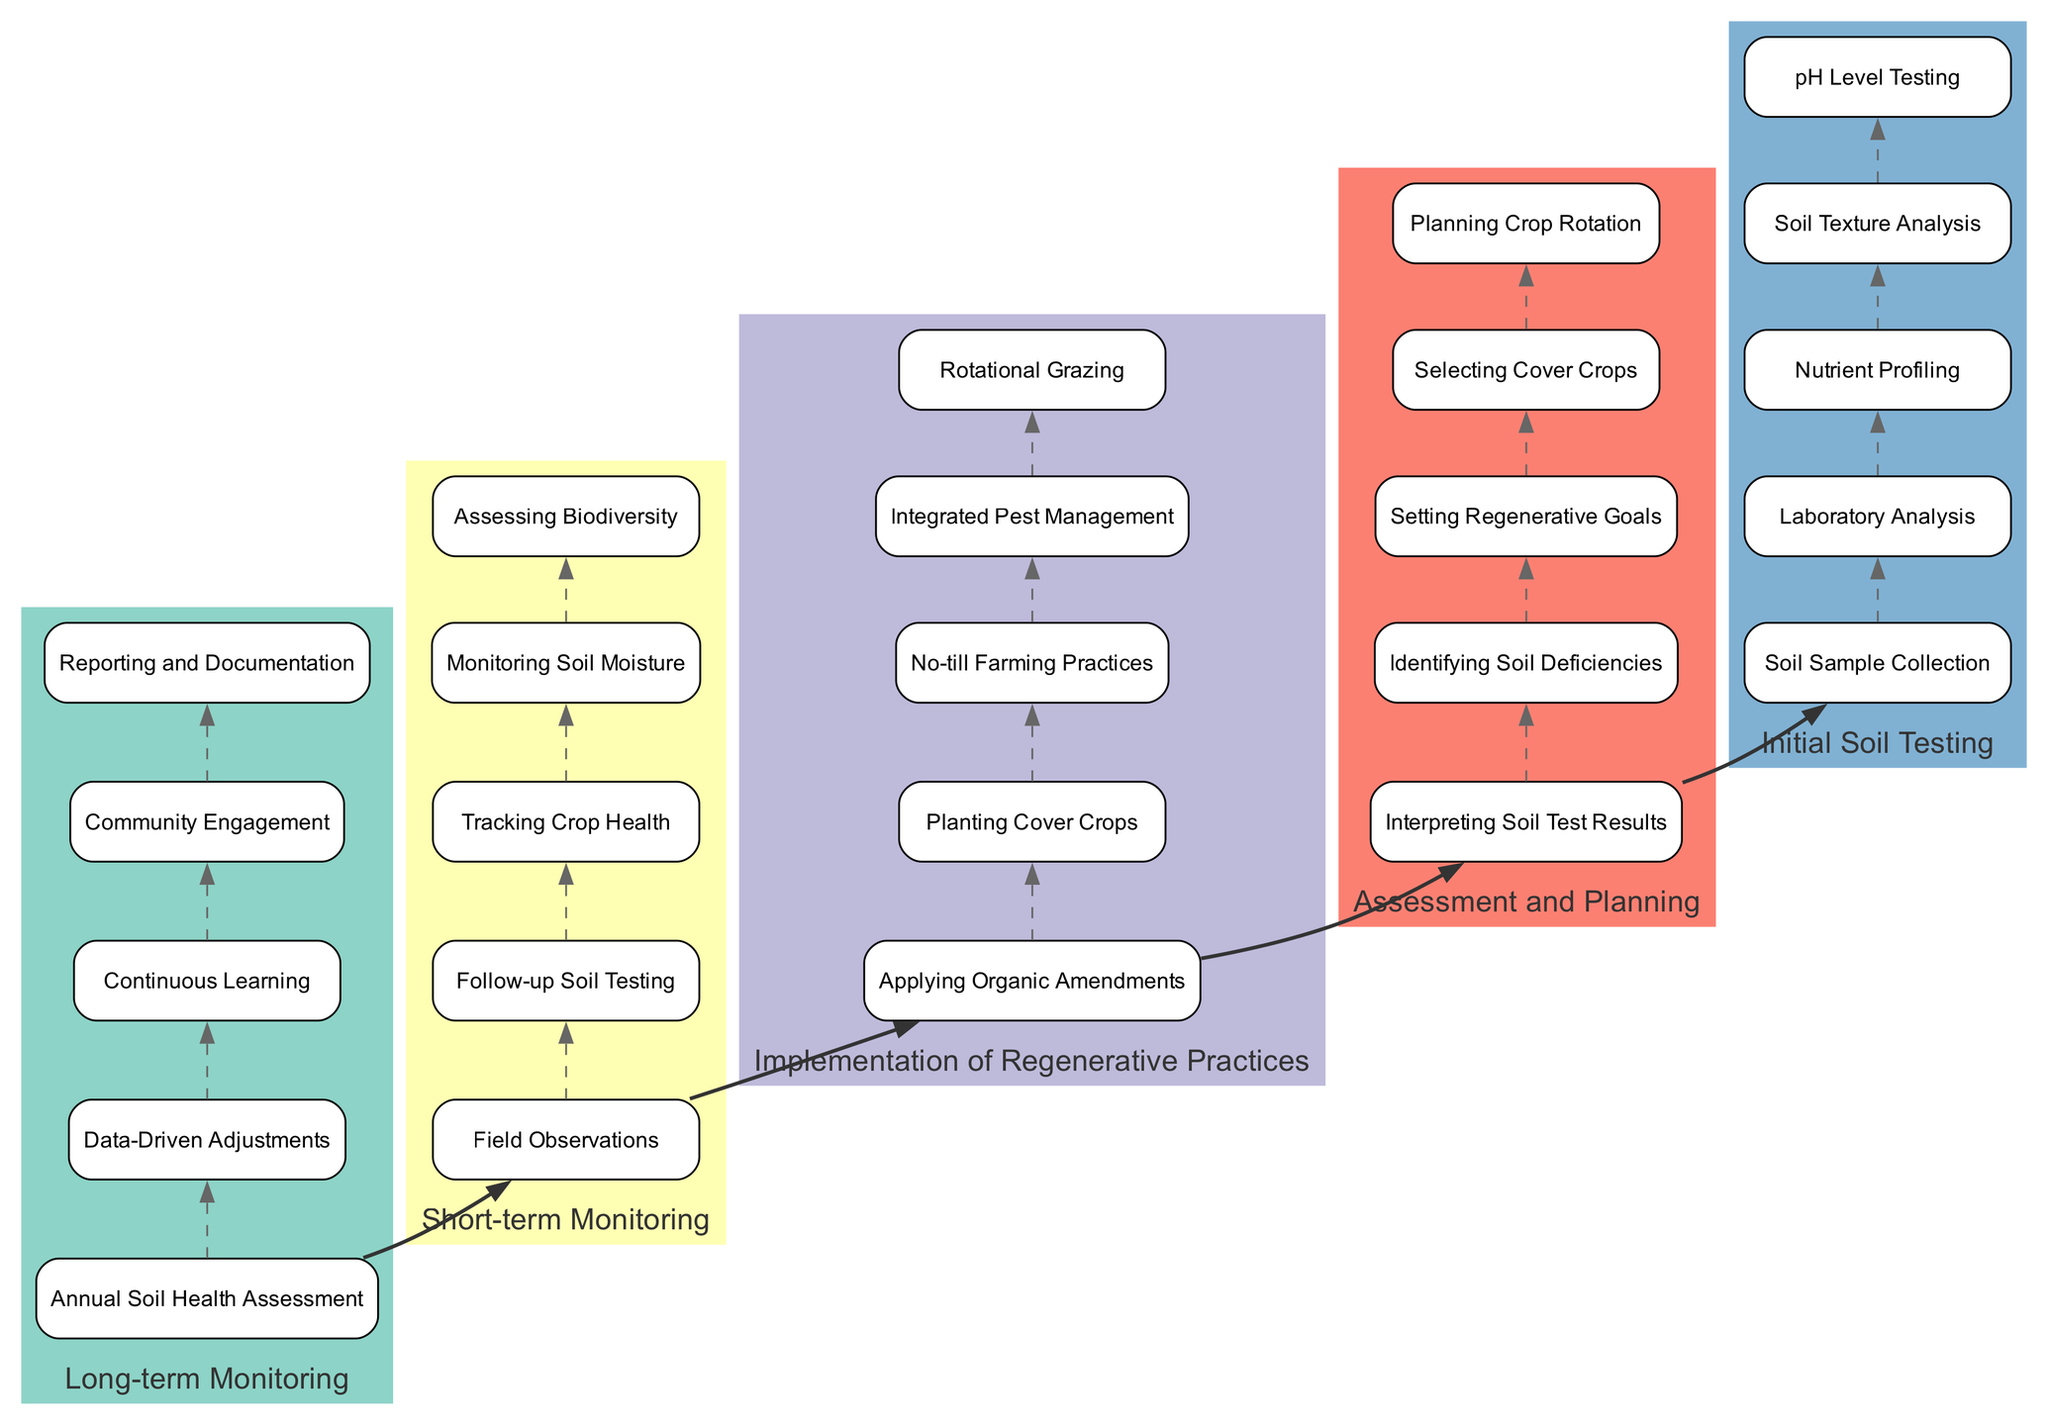what is the first step in the soil health improvement process? The diagram indicates that the first step is "Soil Sample Collection," located at the bottom of the first stage "Initial Soil Testing."
Answer: Soil Sample Collection how many total stages are there in the process? The diagram shows five distinct stages, which include "Initial Soil Testing," "Assessment and Planning," "Implementation of Regenerative Practices," "Short-term Monitoring," and "Long-term Monitoring."
Answer: 5 which stage includes "Setting Regenerative Goals"? The step "Setting Regenerative Goals" is found in the second stage, "Assessment and Planning," as per the diagram layout.
Answer: Assessment and Planning what step follows "No-till Farming Practices"? According to the diagram, "Integrated Pest Management" follows "No-till Farming Practices" in the third stage, "Implementation of Regenerative Practices."
Answer: Integrated Pest Management which two stages are immediately connected? The diagram shows that "Initial Soil Testing" is immediately connected to "Assessment and Planning," indicated by a bold edge between these two stages.
Answer: Initial Soil Testing and Assessment and Planning what is the last step in the long-term monitoring stage? The final step listed in the last stage "Long-term Monitoring" is "Reporting and Documentation," which is prominently displayed at the top of the stage.
Answer: Reporting and Documentation how many steps are in the "Short-term Monitoring" stage? The "Short-term Monitoring" stage contains five steps, as outlined in the diagram.
Answer: 5 what occurs after "Applying Organic Amendments"? Following "Applying Organic Amendments" in the stage "Implementation of Regenerative Practices," the next step is "Planting Cover Crops," based on the flow indicated in the diagram.
Answer: Planting Cover Crops in which step is "Continuous Learning" found? "Continuous Learning" is a part of the final stage "Long-term Monitoring," which is shown at the top of that section of the diagram.
Answer: Long-term Monitoring 